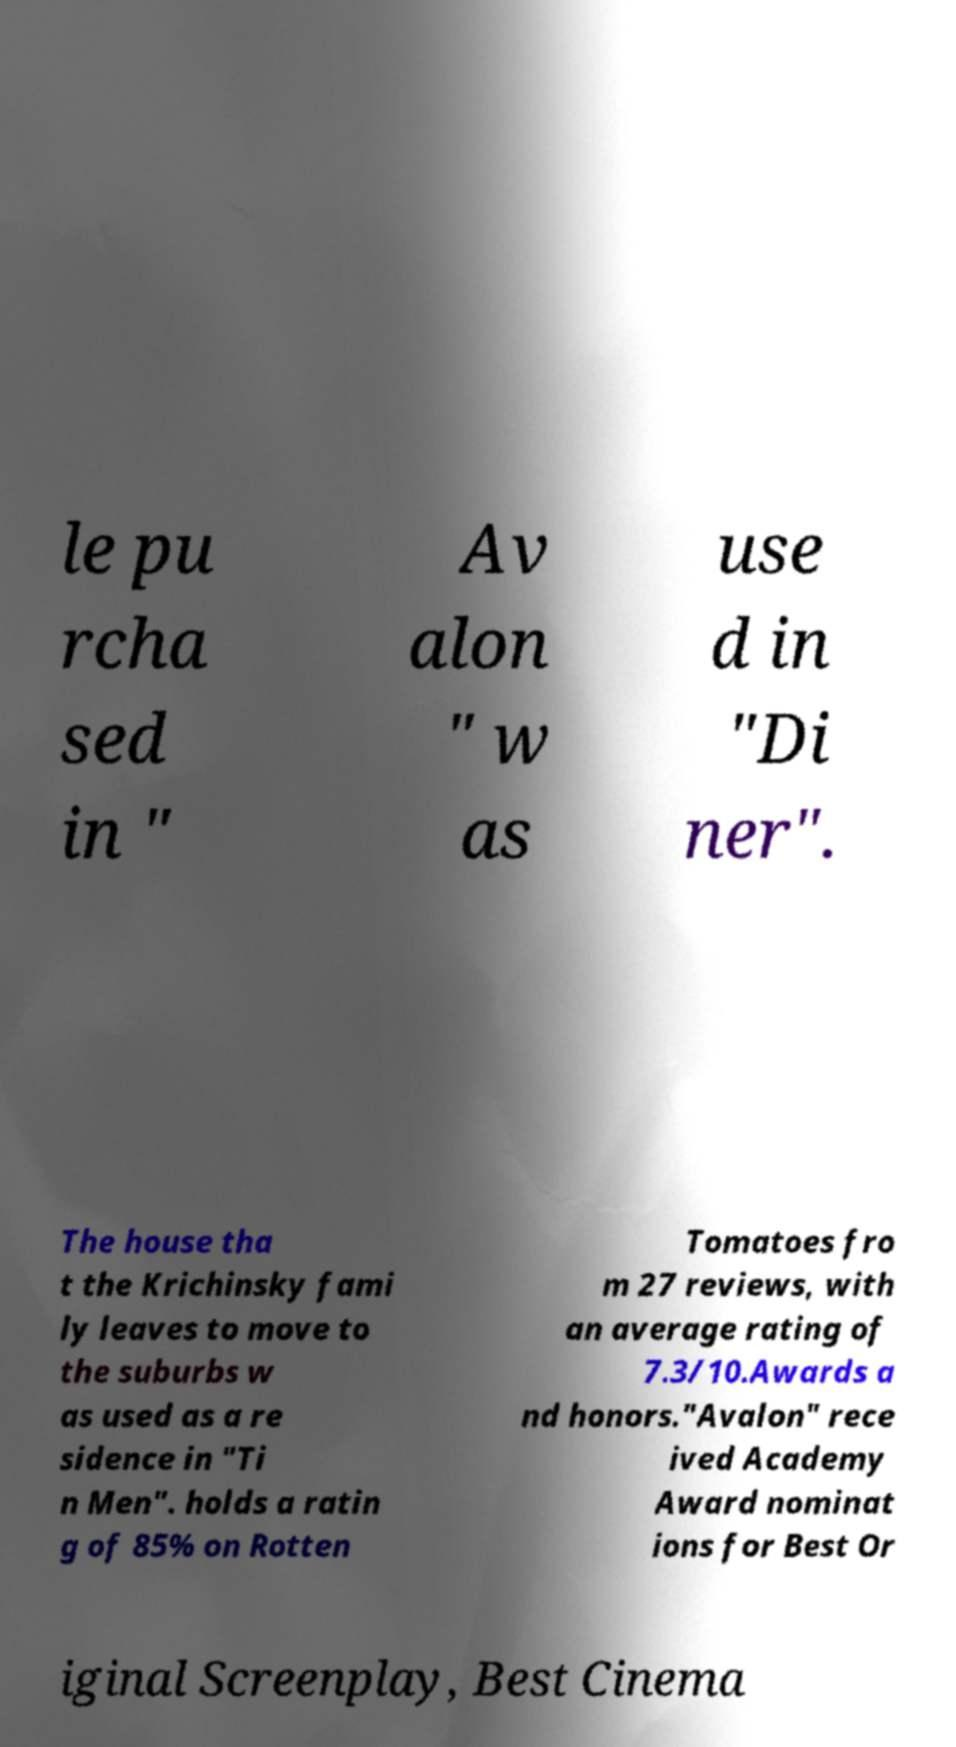There's text embedded in this image that I need extracted. Can you transcribe it verbatim? le pu rcha sed in " Av alon " w as use d in "Di ner". The house tha t the Krichinsky fami ly leaves to move to the suburbs w as used as a re sidence in "Ti n Men". holds a ratin g of 85% on Rotten Tomatoes fro m 27 reviews, with an average rating of 7.3/10.Awards a nd honors."Avalon" rece ived Academy Award nominat ions for Best Or iginal Screenplay, Best Cinema 